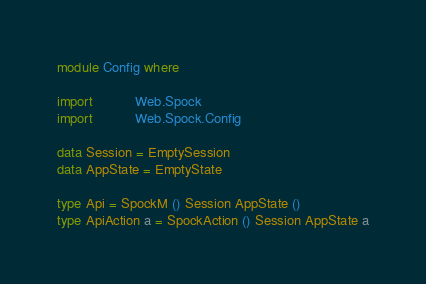Convert code to text. <code><loc_0><loc_0><loc_500><loc_500><_Haskell_>module Config where

import           Web.Spock
import           Web.Spock.Config

data Session = EmptySession
data AppState = EmptyState

type Api = SpockM () Session AppState ()
type ApiAction a = SpockAction () Session AppState a
</code> 